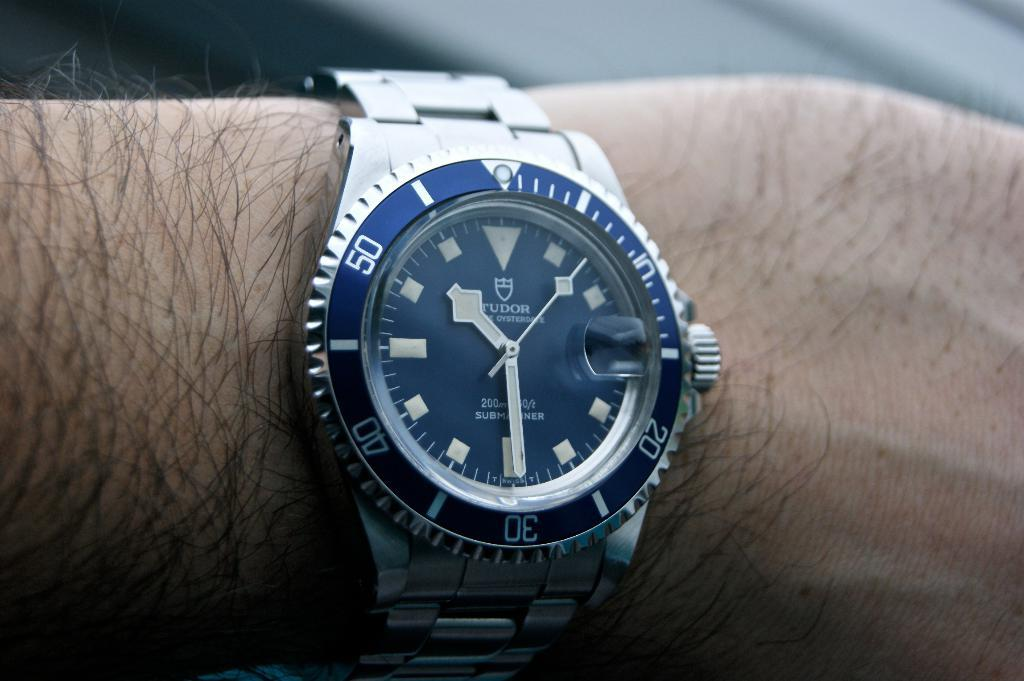<image>
Give a short and clear explanation of the subsequent image. A close up of a watch on a hairy wrist which has the number 50 visible. 